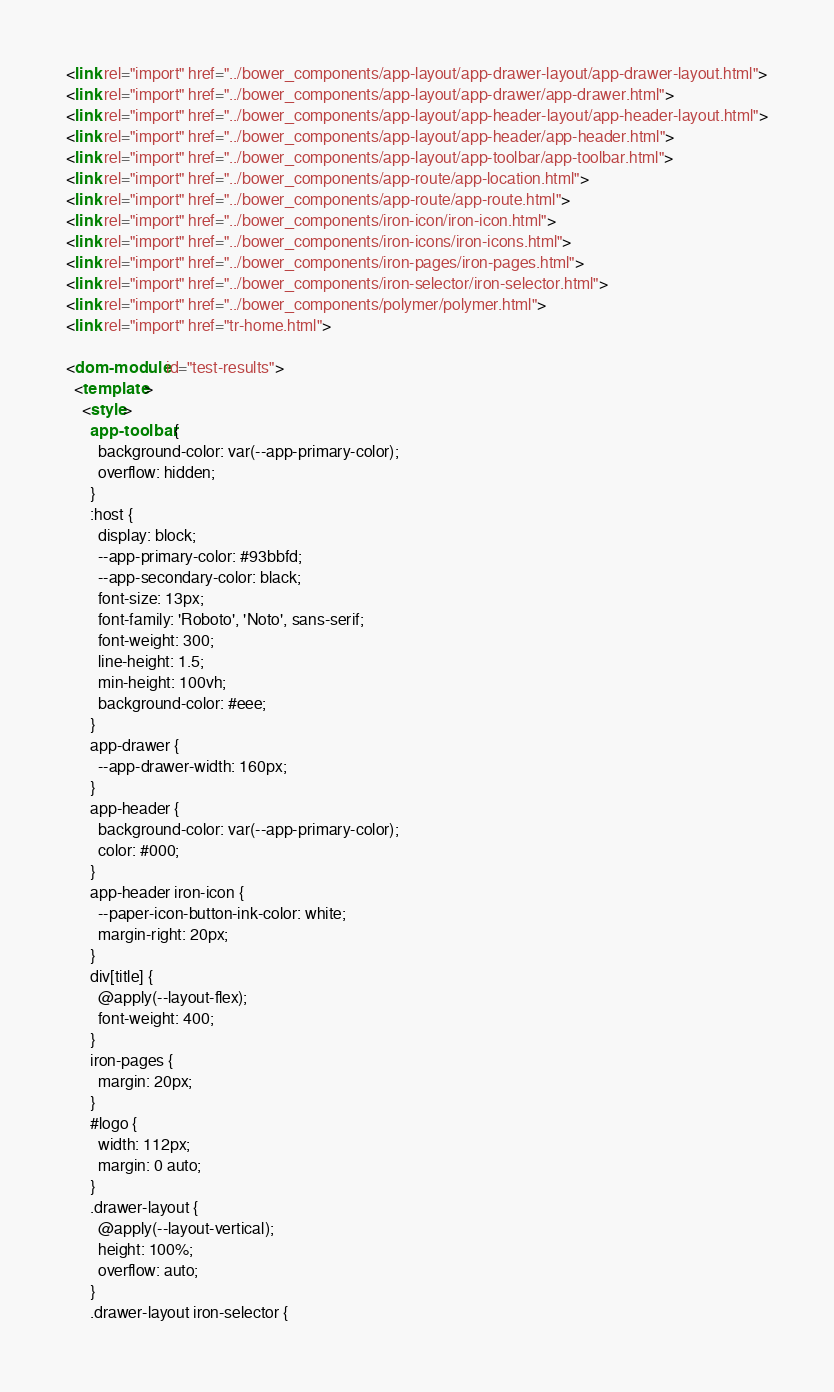Convert code to text. <code><loc_0><loc_0><loc_500><loc_500><_HTML_><link rel="import" href="../bower_components/app-layout/app-drawer-layout/app-drawer-layout.html">
<link rel="import" href="../bower_components/app-layout/app-drawer/app-drawer.html">
<link rel="import" href="../bower_components/app-layout/app-header-layout/app-header-layout.html">
<link rel="import" href="../bower_components/app-layout/app-header/app-header.html">
<link rel="import" href="../bower_components/app-layout/app-toolbar/app-toolbar.html">
<link rel="import" href="../bower_components/app-route/app-location.html">
<link rel="import" href="../bower_components/app-route/app-route.html">
<link rel="import" href="../bower_components/iron-icon/iron-icon.html">
<link rel="import" href="../bower_components/iron-icons/iron-icons.html">
<link rel="import" href="../bower_components/iron-pages/iron-pages.html">
<link rel="import" href="../bower_components/iron-selector/iron-selector.html">
<link rel="import" href="../bower_components/polymer/polymer.html">
<link rel="import" href="tr-home.html">

<dom-module id="test-results">
  <template>
    <style>
      app-toolbar {
        background-color: var(--app-primary-color);
        overflow: hidden;
      }
      :host {
        display: block;
        --app-primary-color: #93bbfd;
        --app-secondary-color: black;
        font-size: 13px;
        font-family: 'Roboto', 'Noto', sans-serif;
        font-weight: 300;
        line-height: 1.5;
        min-height: 100vh;
        background-color: #eee;
      }
      app-drawer {
        --app-drawer-width: 160px;
      }
      app-header {
        background-color: var(--app-primary-color);
        color: #000;
      }
      app-header iron-icon {
        --paper-icon-button-ink-color: white;
        margin-right: 20px;
      }
      div[title] {
        @apply(--layout-flex);
        font-weight: 400;
      }
      iron-pages {
        margin: 20px;
      }
      #logo {
        width: 112px;
        margin: 0 auto;
      }
      .drawer-layout {
        @apply(--layout-vertical);
        height: 100%;
        overflow: auto;
      }
      .drawer-layout iron-selector {</code> 